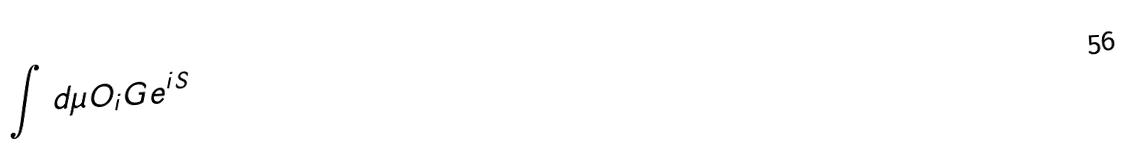Convert formula to latex. <formula><loc_0><loc_0><loc_500><loc_500>\int d \mu O _ { i } G e ^ { i S }</formula> 